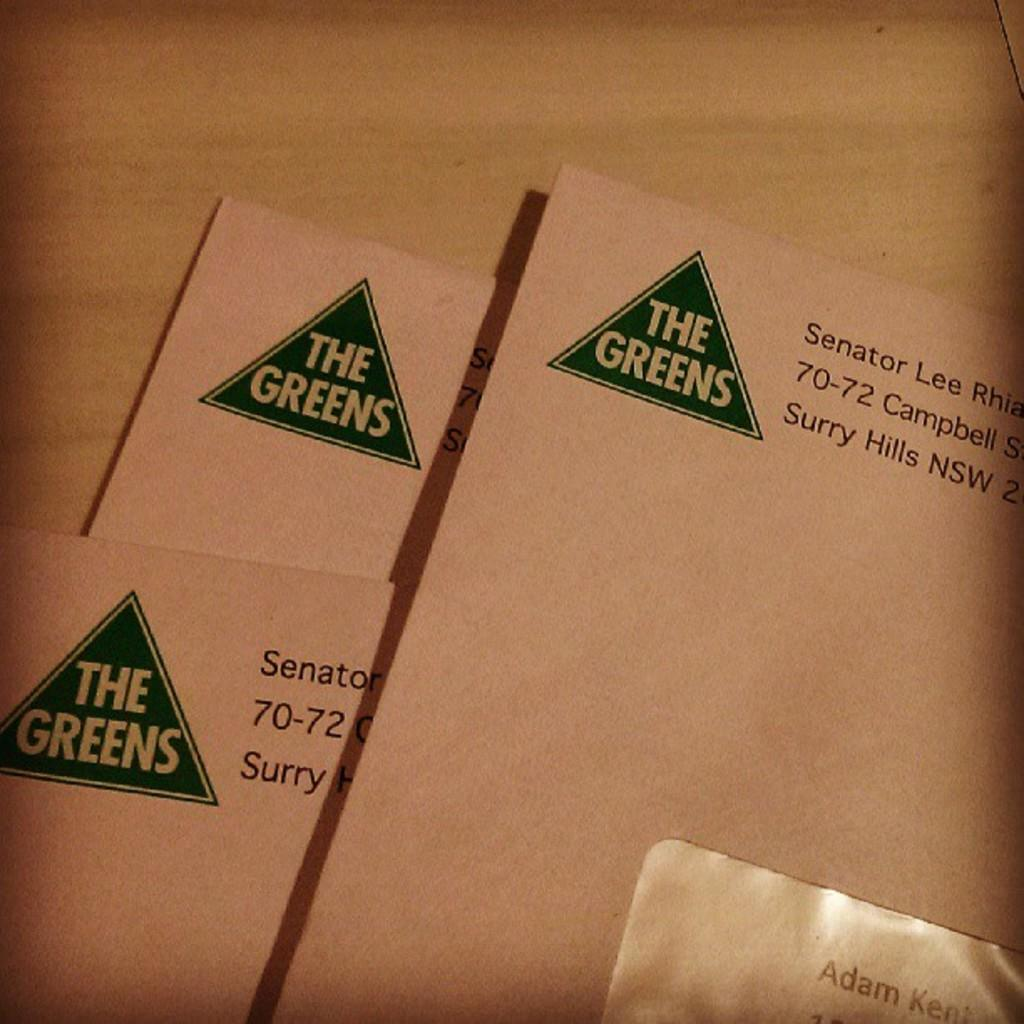<image>
Describe the image concisely. A letter being sent by The Greens is stacked above other letters. 